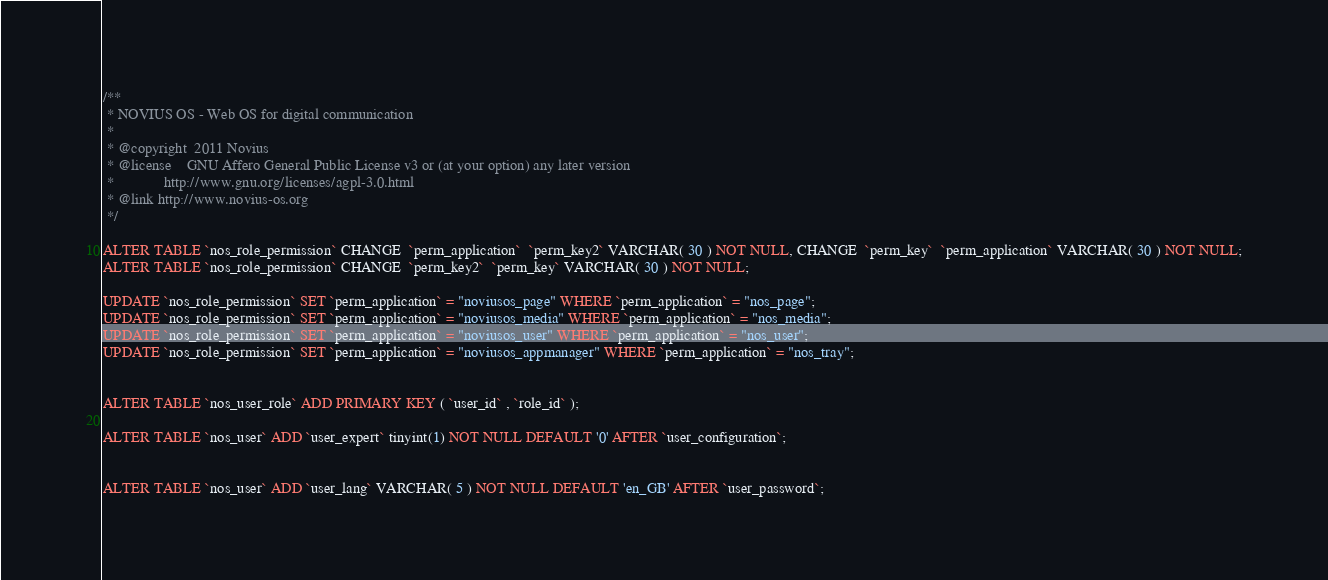Convert code to text. <code><loc_0><loc_0><loc_500><loc_500><_SQL_>/**
 * NOVIUS OS - Web OS for digital communication
 *
 * @copyright  2011 Novius
 * @license    GNU Affero General Public License v3 or (at your option) any later version
 *             http://www.gnu.org/licenses/agpl-3.0.html
 * @link http://www.novius-os.org
 */

ALTER TABLE `nos_role_permission` CHANGE  `perm_application`  `perm_key2` VARCHAR( 30 ) NOT NULL, CHANGE  `perm_key`  `perm_application` VARCHAR( 30 ) NOT NULL;
ALTER TABLE `nos_role_permission` CHANGE  `perm_key2`  `perm_key` VARCHAR( 30 ) NOT NULL;

UPDATE `nos_role_permission` SET `perm_application` = "noviusos_page" WHERE `perm_application` = "nos_page";
UPDATE `nos_role_permission` SET `perm_application` = "noviusos_media" WHERE `perm_application` = "nos_media";
UPDATE `nos_role_permission` SET `perm_application` = "noviusos_user" WHERE `perm_application` = "nos_user";
UPDATE `nos_role_permission` SET `perm_application` = "noviusos_appmanager" WHERE `perm_application` = "nos_tray";


ALTER TABLE `nos_user_role` ADD PRIMARY KEY ( `user_id` , `role_id` );

ALTER TABLE `nos_user` ADD `user_expert` tinyint(1) NOT NULL DEFAULT '0' AFTER `user_configuration`;


ALTER TABLE `nos_user` ADD `user_lang` VARCHAR( 5 ) NOT NULL DEFAULT 'en_GB' AFTER `user_password`;
</code> 